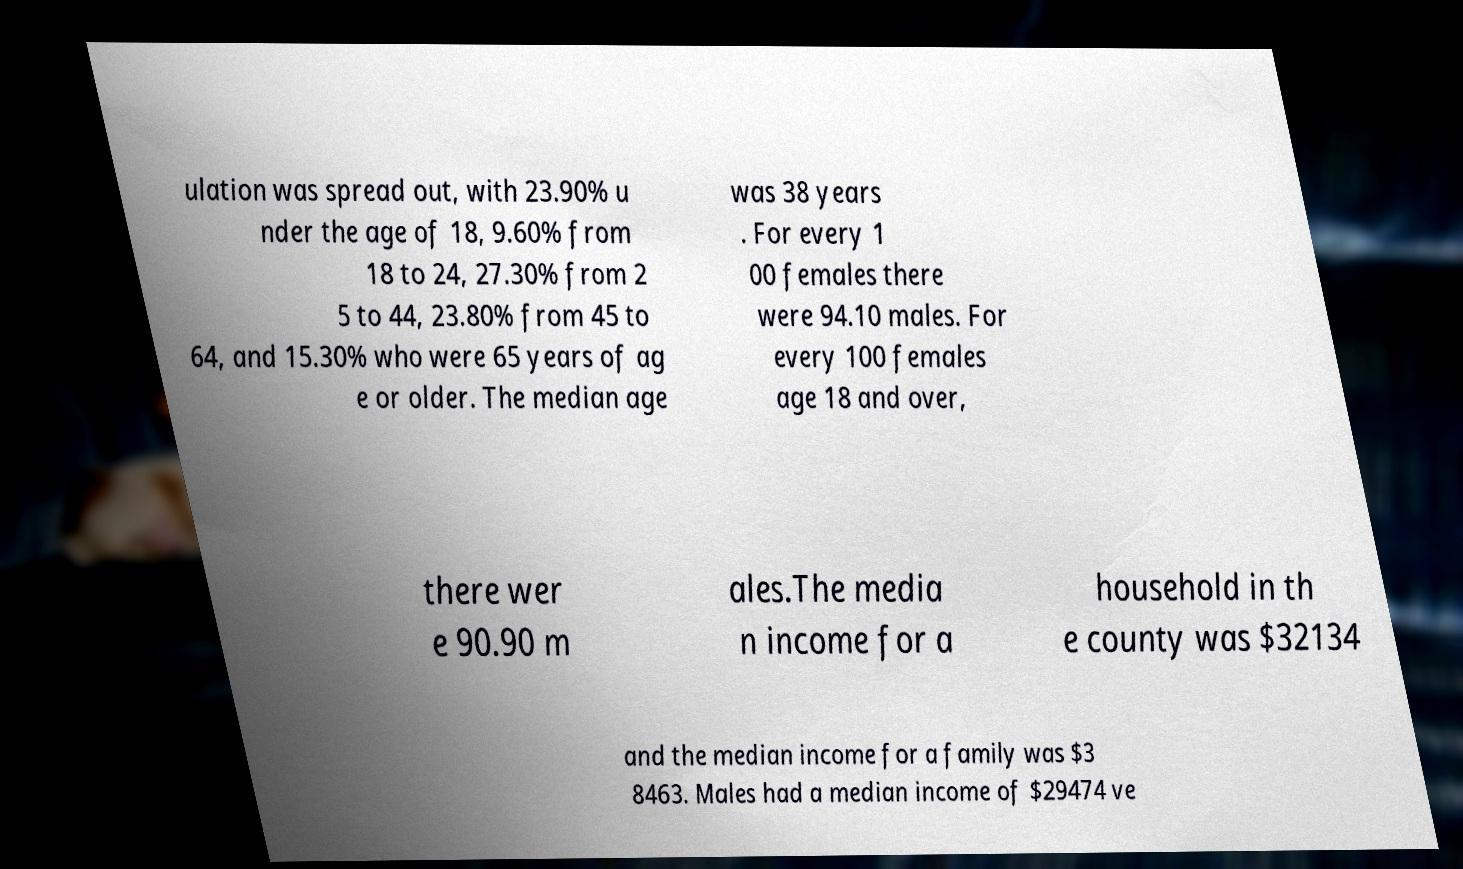Please read and relay the text visible in this image. What does it say? ulation was spread out, with 23.90% u nder the age of 18, 9.60% from 18 to 24, 27.30% from 2 5 to 44, 23.80% from 45 to 64, and 15.30% who were 65 years of ag e or older. The median age was 38 years . For every 1 00 females there were 94.10 males. For every 100 females age 18 and over, there wer e 90.90 m ales.The media n income for a household in th e county was $32134 and the median income for a family was $3 8463. Males had a median income of $29474 ve 